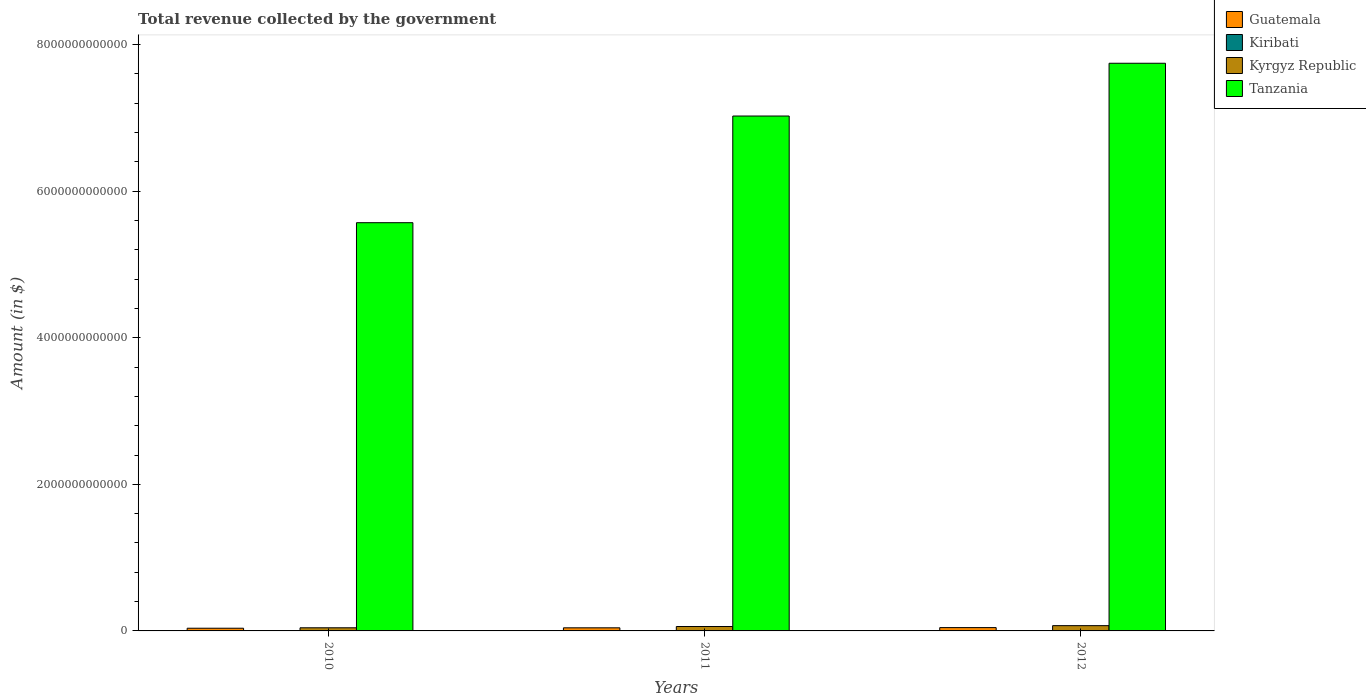How many different coloured bars are there?
Make the answer very short. 4. Are the number of bars per tick equal to the number of legend labels?
Offer a terse response. Yes. Are the number of bars on each tick of the X-axis equal?
Give a very brief answer. Yes. How many bars are there on the 1st tick from the left?
Ensure brevity in your answer.  4. What is the total revenue collected by the government in Kyrgyz Republic in 2011?
Your response must be concise. 6.03e+1. Across all years, what is the maximum total revenue collected by the government in Kyrgyz Republic?
Provide a succinct answer. 7.19e+1. Across all years, what is the minimum total revenue collected by the government in Guatemala?
Make the answer very short. 3.69e+1. In which year was the total revenue collected by the government in Tanzania maximum?
Your response must be concise. 2012. In which year was the total revenue collected by the government in Guatemala minimum?
Give a very brief answer. 2010. What is the total total revenue collected by the government in Guatemala in the graph?
Offer a very short reply. 1.24e+11. What is the difference between the total revenue collected by the government in Kyrgyz Republic in 2010 and that in 2012?
Make the answer very short. -2.91e+1. What is the difference between the total revenue collected by the government in Tanzania in 2011 and the total revenue collected by the government in Kiribati in 2010?
Offer a terse response. 7.03e+12. What is the average total revenue collected by the government in Kyrgyz Republic per year?
Offer a terse response. 5.83e+1. In the year 2010, what is the difference between the total revenue collected by the government in Kiribati and total revenue collected by the government in Kyrgyz Republic?
Your response must be concise. -4.27e+1. In how many years, is the total revenue collected by the government in Guatemala greater than 7600000000000 $?
Ensure brevity in your answer.  0. What is the ratio of the total revenue collected by the government in Tanzania in 2011 to that in 2012?
Offer a terse response. 0.91. Is the total revenue collected by the government in Kyrgyz Republic in 2011 less than that in 2012?
Provide a short and direct response. Yes. Is the difference between the total revenue collected by the government in Kiribati in 2010 and 2012 greater than the difference between the total revenue collected by the government in Kyrgyz Republic in 2010 and 2012?
Make the answer very short. Yes. What is the difference between the highest and the second highest total revenue collected by the government in Kyrgyz Republic?
Offer a very short reply. 1.16e+1. What is the difference between the highest and the lowest total revenue collected by the government in Kyrgyz Republic?
Offer a very short reply. 2.91e+1. In how many years, is the total revenue collected by the government in Guatemala greater than the average total revenue collected by the government in Guatemala taken over all years?
Your answer should be compact. 2. What does the 2nd bar from the left in 2011 represents?
Your answer should be very brief. Kiribati. What does the 1st bar from the right in 2011 represents?
Your response must be concise. Tanzania. How many years are there in the graph?
Your answer should be very brief. 3. What is the difference between two consecutive major ticks on the Y-axis?
Your answer should be very brief. 2.00e+12. Are the values on the major ticks of Y-axis written in scientific E-notation?
Provide a short and direct response. No. How are the legend labels stacked?
Make the answer very short. Vertical. What is the title of the graph?
Provide a short and direct response. Total revenue collected by the government. What is the label or title of the X-axis?
Your answer should be very brief. Years. What is the label or title of the Y-axis?
Make the answer very short. Amount (in $). What is the Amount (in $) in Guatemala in 2010?
Offer a very short reply. 3.69e+1. What is the Amount (in $) of Kiribati in 2010?
Keep it short and to the point. 9.63e+07. What is the Amount (in $) of Kyrgyz Republic in 2010?
Give a very brief answer. 4.28e+1. What is the Amount (in $) in Tanzania in 2010?
Make the answer very short. 5.57e+12. What is the Amount (in $) of Guatemala in 2011?
Give a very brief answer. 4.23e+1. What is the Amount (in $) in Kiribati in 2011?
Keep it short and to the point. 8.50e+07. What is the Amount (in $) in Kyrgyz Republic in 2011?
Offer a terse response. 6.03e+1. What is the Amount (in $) in Tanzania in 2011?
Ensure brevity in your answer.  7.03e+12. What is the Amount (in $) of Guatemala in 2012?
Your response must be concise. 4.53e+1. What is the Amount (in $) of Kiribati in 2012?
Provide a succinct answer. 1.12e+08. What is the Amount (in $) of Kyrgyz Republic in 2012?
Keep it short and to the point. 7.19e+1. What is the Amount (in $) in Tanzania in 2012?
Ensure brevity in your answer.  7.75e+12. Across all years, what is the maximum Amount (in $) of Guatemala?
Provide a succinct answer. 4.53e+1. Across all years, what is the maximum Amount (in $) of Kiribati?
Your response must be concise. 1.12e+08. Across all years, what is the maximum Amount (in $) of Kyrgyz Republic?
Provide a succinct answer. 7.19e+1. Across all years, what is the maximum Amount (in $) in Tanzania?
Provide a short and direct response. 7.75e+12. Across all years, what is the minimum Amount (in $) of Guatemala?
Offer a very short reply. 3.69e+1. Across all years, what is the minimum Amount (in $) of Kiribati?
Make the answer very short. 8.50e+07. Across all years, what is the minimum Amount (in $) of Kyrgyz Republic?
Your response must be concise. 4.28e+1. Across all years, what is the minimum Amount (in $) in Tanzania?
Offer a very short reply. 5.57e+12. What is the total Amount (in $) of Guatemala in the graph?
Make the answer very short. 1.24e+11. What is the total Amount (in $) in Kiribati in the graph?
Your answer should be compact. 2.94e+08. What is the total Amount (in $) of Kyrgyz Republic in the graph?
Provide a short and direct response. 1.75e+11. What is the total Amount (in $) in Tanzania in the graph?
Offer a very short reply. 2.03e+13. What is the difference between the Amount (in $) of Guatemala in 2010 and that in 2011?
Offer a very short reply. -5.42e+09. What is the difference between the Amount (in $) of Kiribati in 2010 and that in 2011?
Keep it short and to the point. 1.13e+07. What is the difference between the Amount (in $) of Kyrgyz Republic in 2010 and that in 2011?
Ensure brevity in your answer.  -1.75e+1. What is the difference between the Amount (in $) in Tanzania in 2010 and that in 2011?
Ensure brevity in your answer.  -1.46e+12. What is the difference between the Amount (in $) in Guatemala in 2010 and that in 2012?
Your response must be concise. -8.40e+09. What is the difference between the Amount (in $) in Kiribati in 2010 and that in 2012?
Make the answer very short. -1.61e+07. What is the difference between the Amount (in $) in Kyrgyz Republic in 2010 and that in 2012?
Your answer should be very brief. -2.91e+1. What is the difference between the Amount (in $) of Tanzania in 2010 and that in 2012?
Your answer should be compact. -2.18e+12. What is the difference between the Amount (in $) of Guatemala in 2011 and that in 2012?
Offer a terse response. -2.98e+09. What is the difference between the Amount (in $) in Kiribati in 2011 and that in 2012?
Make the answer very short. -2.74e+07. What is the difference between the Amount (in $) of Kyrgyz Republic in 2011 and that in 2012?
Offer a very short reply. -1.16e+1. What is the difference between the Amount (in $) in Tanzania in 2011 and that in 2012?
Make the answer very short. -7.20e+11. What is the difference between the Amount (in $) of Guatemala in 2010 and the Amount (in $) of Kiribati in 2011?
Your answer should be very brief. 3.68e+1. What is the difference between the Amount (in $) in Guatemala in 2010 and the Amount (in $) in Kyrgyz Republic in 2011?
Your response must be concise. -2.34e+1. What is the difference between the Amount (in $) in Guatemala in 2010 and the Amount (in $) in Tanzania in 2011?
Provide a succinct answer. -6.99e+12. What is the difference between the Amount (in $) in Kiribati in 2010 and the Amount (in $) in Kyrgyz Republic in 2011?
Keep it short and to the point. -6.02e+1. What is the difference between the Amount (in $) in Kiribati in 2010 and the Amount (in $) in Tanzania in 2011?
Ensure brevity in your answer.  -7.03e+12. What is the difference between the Amount (in $) of Kyrgyz Republic in 2010 and the Amount (in $) of Tanzania in 2011?
Your answer should be very brief. -6.98e+12. What is the difference between the Amount (in $) in Guatemala in 2010 and the Amount (in $) in Kiribati in 2012?
Provide a short and direct response. 3.68e+1. What is the difference between the Amount (in $) of Guatemala in 2010 and the Amount (in $) of Kyrgyz Republic in 2012?
Offer a very short reply. -3.50e+1. What is the difference between the Amount (in $) in Guatemala in 2010 and the Amount (in $) in Tanzania in 2012?
Make the answer very short. -7.71e+12. What is the difference between the Amount (in $) of Kiribati in 2010 and the Amount (in $) of Kyrgyz Republic in 2012?
Your answer should be compact. -7.18e+1. What is the difference between the Amount (in $) in Kiribati in 2010 and the Amount (in $) in Tanzania in 2012?
Your answer should be compact. -7.75e+12. What is the difference between the Amount (in $) in Kyrgyz Republic in 2010 and the Amount (in $) in Tanzania in 2012?
Offer a terse response. -7.70e+12. What is the difference between the Amount (in $) of Guatemala in 2011 and the Amount (in $) of Kiribati in 2012?
Offer a terse response. 4.22e+1. What is the difference between the Amount (in $) in Guatemala in 2011 and the Amount (in $) in Kyrgyz Republic in 2012?
Keep it short and to the point. -2.96e+1. What is the difference between the Amount (in $) in Guatemala in 2011 and the Amount (in $) in Tanzania in 2012?
Offer a terse response. -7.70e+12. What is the difference between the Amount (in $) in Kiribati in 2011 and the Amount (in $) in Kyrgyz Republic in 2012?
Offer a very short reply. -7.18e+1. What is the difference between the Amount (in $) of Kiribati in 2011 and the Amount (in $) of Tanzania in 2012?
Ensure brevity in your answer.  -7.75e+12. What is the difference between the Amount (in $) in Kyrgyz Republic in 2011 and the Amount (in $) in Tanzania in 2012?
Offer a very short reply. -7.69e+12. What is the average Amount (in $) of Guatemala per year?
Make the answer very short. 4.15e+1. What is the average Amount (in $) in Kiribati per year?
Provide a short and direct response. 9.79e+07. What is the average Amount (in $) of Kyrgyz Republic per year?
Give a very brief answer. 5.83e+1. What is the average Amount (in $) in Tanzania per year?
Offer a terse response. 6.78e+12. In the year 2010, what is the difference between the Amount (in $) of Guatemala and Amount (in $) of Kiribati?
Keep it short and to the point. 3.68e+1. In the year 2010, what is the difference between the Amount (in $) in Guatemala and Amount (in $) in Kyrgyz Republic?
Your answer should be compact. -5.92e+09. In the year 2010, what is the difference between the Amount (in $) in Guatemala and Amount (in $) in Tanzania?
Offer a terse response. -5.53e+12. In the year 2010, what is the difference between the Amount (in $) in Kiribati and Amount (in $) in Kyrgyz Republic?
Keep it short and to the point. -4.27e+1. In the year 2010, what is the difference between the Amount (in $) of Kiribati and Amount (in $) of Tanzania?
Ensure brevity in your answer.  -5.57e+12. In the year 2010, what is the difference between the Amount (in $) of Kyrgyz Republic and Amount (in $) of Tanzania?
Make the answer very short. -5.53e+12. In the year 2011, what is the difference between the Amount (in $) of Guatemala and Amount (in $) of Kiribati?
Offer a terse response. 4.22e+1. In the year 2011, what is the difference between the Amount (in $) in Guatemala and Amount (in $) in Kyrgyz Republic?
Your answer should be very brief. -1.80e+1. In the year 2011, what is the difference between the Amount (in $) in Guatemala and Amount (in $) in Tanzania?
Provide a short and direct response. -6.98e+12. In the year 2011, what is the difference between the Amount (in $) of Kiribati and Amount (in $) of Kyrgyz Republic?
Ensure brevity in your answer.  -6.02e+1. In the year 2011, what is the difference between the Amount (in $) in Kiribati and Amount (in $) in Tanzania?
Offer a very short reply. -7.03e+12. In the year 2011, what is the difference between the Amount (in $) in Kyrgyz Republic and Amount (in $) in Tanzania?
Your answer should be compact. -6.97e+12. In the year 2012, what is the difference between the Amount (in $) of Guatemala and Amount (in $) of Kiribati?
Keep it short and to the point. 4.52e+1. In the year 2012, what is the difference between the Amount (in $) of Guatemala and Amount (in $) of Kyrgyz Republic?
Your answer should be compact. -2.66e+1. In the year 2012, what is the difference between the Amount (in $) in Guatemala and Amount (in $) in Tanzania?
Provide a short and direct response. -7.70e+12. In the year 2012, what is the difference between the Amount (in $) in Kiribati and Amount (in $) in Kyrgyz Republic?
Offer a terse response. -7.18e+1. In the year 2012, what is the difference between the Amount (in $) in Kiribati and Amount (in $) in Tanzania?
Offer a terse response. -7.75e+12. In the year 2012, what is the difference between the Amount (in $) of Kyrgyz Republic and Amount (in $) of Tanzania?
Your answer should be compact. -7.67e+12. What is the ratio of the Amount (in $) of Guatemala in 2010 to that in 2011?
Keep it short and to the point. 0.87. What is the ratio of the Amount (in $) in Kiribati in 2010 to that in 2011?
Offer a terse response. 1.13. What is the ratio of the Amount (in $) in Kyrgyz Republic in 2010 to that in 2011?
Your answer should be very brief. 0.71. What is the ratio of the Amount (in $) in Tanzania in 2010 to that in 2011?
Keep it short and to the point. 0.79. What is the ratio of the Amount (in $) in Guatemala in 2010 to that in 2012?
Keep it short and to the point. 0.81. What is the ratio of the Amount (in $) in Kiribati in 2010 to that in 2012?
Your response must be concise. 0.86. What is the ratio of the Amount (in $) of Kyrgyz Republic in 2010 to that in 2012?
Your response must be concise. 0.6. What is the ratio of the Amount (in $) in Tanzania in 2010 to that in 2012?
Your response must be concise. 0.72. What is the ratio of the Amount (in $) of Guatemala in 2011 to that in 2012?
Provide a short and direct response. 0.93. What is the ratio of the Amount (in $) of Kiribati in 2011 to that in 2012?
Provide a short and direct response. 0.76. What is the ratio of the Amount (in $) in Kyrgyz Republic in 2011 to that in 2012?
Your answer should be compact. 0.84. What is the ratio of the Amount (in $) of Tanzania in 2011 to that in 2012?
Provide a short and direct response. 0.91. What is the difference between the highest and the second highest Amount (in $) in Guatemala?
Ensure brevity in your answer.  2.98e+09. What is the difference between the highest and the second highest Amount (in $) of Kiribati?
Keep it short and to the point. 1.61e+07. What is the difference between the highest and the second highest Amount (in $) of Kyrgyz Republic?
Provide a succinct answer. 1.16e+1. What is the difference between the highest and the second highest Amount (in $) of Tanzania?
Your response must be concise. 7.20e+11. What is the difference between the highest and the lowest Amount (in $) of Guatemala?
Your answer should be very brief. 8.40e+09. What is the difference between the highest and the lowest Amount (in $) in Kiribati?
Your response must be concise. 2.74e+07. What is the difference between the highest and the lowest Amount (in $) of Kyrgyz Republic?
Offer a very short reply. 2.91e+1. What is the difference between the highest and the lowest Amount (in $) in Tanzania?
Offer a terse response. 2.18e+12. 